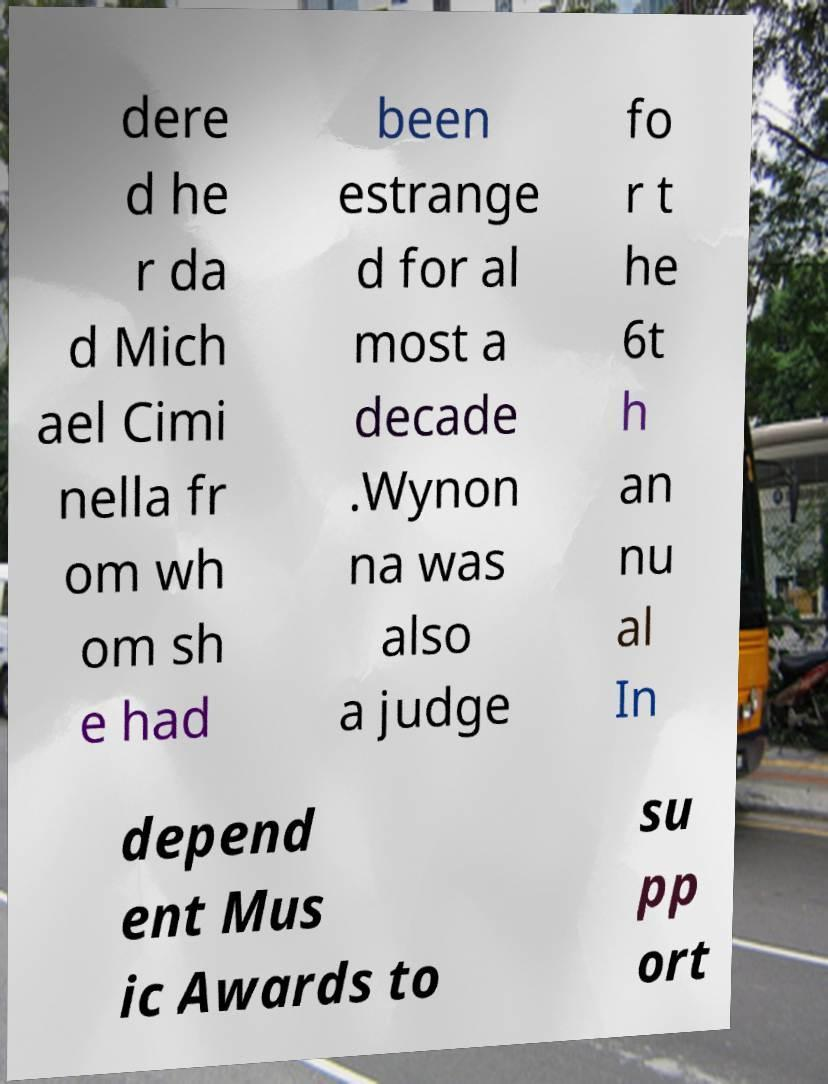I need the written content from this picture converted into text. Can you do that? dere d he r da d Mich ael Cimi nella fr om wh om sh e had been estrange d for al most a decade .Wynon na was also a judge fo r t he 6t h an nu al In depend ent Mus ic Awards to su pp ort 